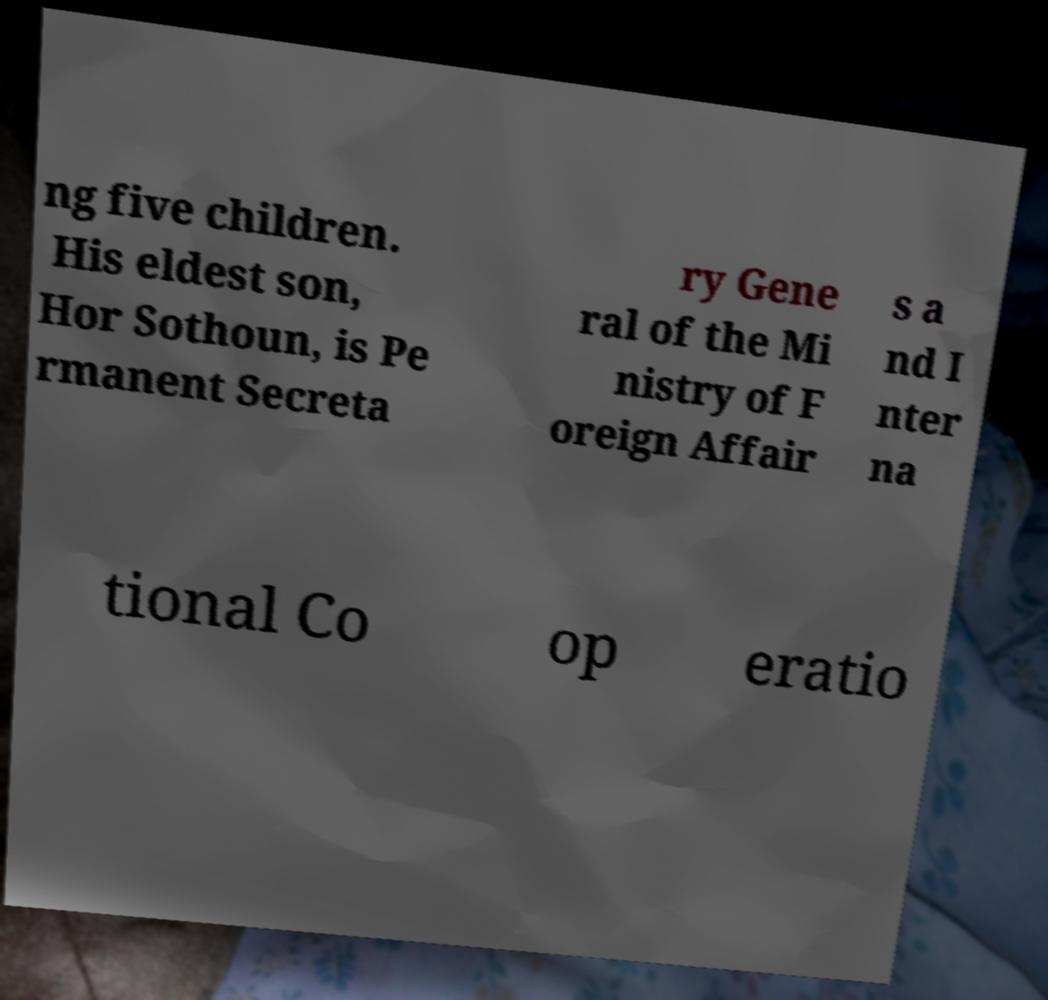Can you read and provide the text displayed in the image?This photo seems to have some interesting text. Can you extract and type it out for me? ng five children. His eldest son, Hor Sothoun, is Pe rmanent Secreta ry Gene ral of the Mi nistry of F oreign Affair s a nd I nter na tional Co op eratio 